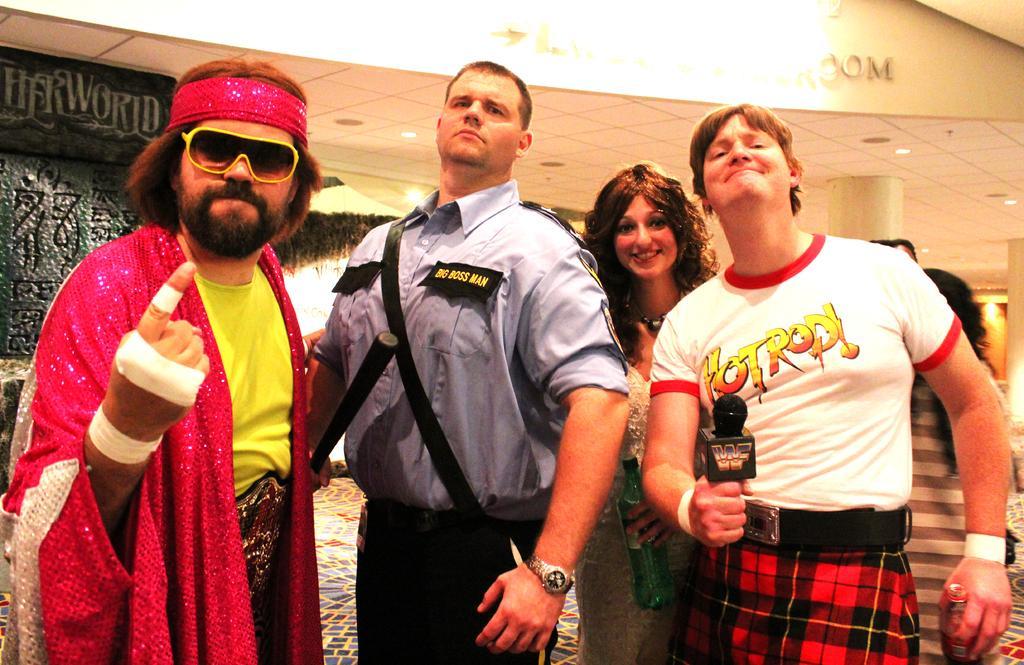How would you summarize this image in a sentence or two? In this image we can see a few people standing and holding few objects, behind there is a wall and some text written on it, there is a ceiling with the lights, there are few pillars. 